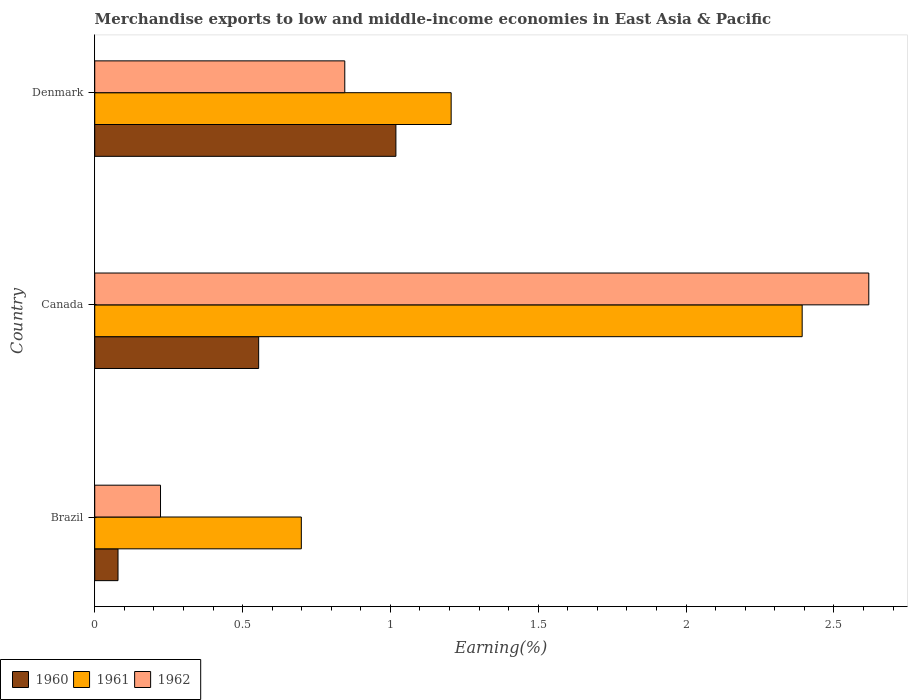How many different coloured bars are there?
Your answer should be compact. 3. How many groups of bars are there?
Your answer should be very brief. 3. Are the number of bars per tick equal to the number of legend labels?
Give a very brief answer. Yes. How many bars are there on the 1st tick from the bottom?
Your response must be concise. 3. What is the label of the 2nd group of bars from the top?
Give a very brief answer. Canada. In how many cases, is the number of bars for a given country not equal to the number of legend labels?
Make the answer very short. 0. What is the percentage of amount earned from merchandise exports in 1962 in Denmark?
Give a very brief answer. 0.85. Across all countries, what is the maximum percentage of amount earned from merchandise exports in 1960?
Your response must be concise. 1.02. Across all countries, what is the minimum percentage of amount earned from merchandise exports in 1962?
Keep it short and to the point. 0.22. What is the total percentage of amount earned from merchandise exports in 1961 in the graph?
Ensure brevity in your answer.  4.3. What is the difference between the percentage of amount earned from merchandise exports in 1961 in Brazil and that in Canada?
Make the answer very short. -1.69. What is the difference between the percentage of amount earned from merchandise exports in 1961 in Denmark and the percentage of amount earned from merchandise exports in 1962 in Canada?
Provide a succinct answer. -1.41. What is the average percentage of amount earned from merchandise exports in 1960 per country?
Provide a short and direct response. 0.55. What is the difference between the percentage of amount earned from merchandise exports in 1962 and percentage of amount earned from merchandise exports in 1961 in Denmark?
Ensure brevity in your answer.  -0.36. In how many countries, is the percentage of amount earned from merchandise exports in 1960 greater than 2.1 %?
Your response must be concise. 0. What is the ratio of the percentage of amount earned from merchandise exports in 1961 in Brazil to that in Denmark?
Make the answer very short. 0.58. Is the percentage of amount earned from merchandise exports in 1961 in Brazil less than that in Denmark?
Ensure brevity in your answer.  Yes. What is the difference between the highest and the second highest percentage of amount earned from merchandise exports in 1962?
Your response must be concise. 1.77. What is the difference between the highest and the lowest percentage of amount earned from merchandise exports in 1962?
Provide a succinct answer. 2.4. Is the sum of the percentage of amount earned from merchandise exports in 1961 in Brazil and Canada greater than the maximum percentage of amount earned from merchandise exports in 1962 across all countries?
Your answer should be compact. Yes. Is it the case that in every country, the sum of the percentage of amount earned from merchandise exports in 1960 and percentage of amount earned from merchandise exports in 1961 is greater than the percentage of amount earned from merchandise exports in 1962?
Keep it short and to the point. Yes. How many bars are there?
Your response must be concise. 9. Does the graph contain any zero values?
Offer a terse response. No. Where does the legend appear in the graph?
Your answer should be very brief. Bottom left. How many legend labels are there?
Provide a short and direct response. 3. How are the legend labels stacked?
Provide a short and direct response. Horizontal. What is the title of the graph?
Your response must be concise. Merchandise exports to low and middle-income economies in East Asia & Pacific. What is the label or title of the X-axis?
Provide a short and direct response. Earning(%). What is the Earning(%) in 1960 in Brazil?
Offer a terse response. 0.08. What is the Earning(%) in 1961 in Brazil?
Offer a very short reply. 0.7. What is the Earning(%) of 1962 in Brazil?
Provide a succinct answer. 0.22. What is the Earning(%) of 1960 in Canada?
Provide a short and direct response. 0.55. What is the Earning(%) of 1961 in Canada?
Offer a terse response. 2.39. What is the Earning(%) of 1962 in Canada?
Your answer should be compact. 2.62. What is the Earning(%) in 1960 in Denmark?
Offer a terse response. 1.02. What is the Earning(%) in 1961 in Denmark?
Your response must be concise. 1.21. What is the Earning(%) of 1962 in Denmark?
Keep it short and to the point. 0.85. Across all countries, what is the maximum Earning(%) of 1960?
Give a very brief answer. 1.02. Across all countries, what is the maximum Earning(%) of 1961?
Keep it short and to the point. 2.39. Across all countries, what is the maximum Earning(%) in 1962?
Your response must be concise. 2.62. Across all countries, what is the minimum Earning(%) of 1960?
Your answer should be very brief. 0.08. Across all countries, what is the minimum Earning(%) in 1961?
Your response must be concise. 0.7. Across all countries, what is the minimum Earning(%) in 1962?
Provide a succinct answer. 0.22. What is the total Earning(%) in 1960 in the graph?
Provide a short and direct response. 1.65. What is the total Earning(%) in 1961 in the graph?
Your answer should be very brief. 4.3. What is the total Earning(%) in 1962 in the graph?
Offer a terse response. 3.69. What is the difference between the Earning(%) in 1960 in Brazil and that in Canada?
Provide a succinct answer. -0.48. What is the difference between the Earning(%) in 1961 in Brazil and that in Canada?
Keep it short and to the point. -1.69. What is the difference between the Earning(%) of 1962 in Brazil and that in Canada?
Your answer should be very brief. -2.4. What is the difference between the Earning(%) of 1960 in Brazil and that in Denmark?
Ensure brevity in your answer.  -0.94. What is the difference between the Earning(%) in 1961 in Brazil and that in Denmark?
Your answer should be very brief. -0.51. What is the difference between the Earning(%) in 1962 in Brazil and that in Denmark?
Give a very brief answer. -0.62. What is the difference between the Earning(%) of 1960 in Canada and that in Denmark?
Provide a succinct answer. -0.46. What is the difference between the Earning(%) of 1961 in Canada and that in Denmark?
Your response must be concise. 1.19. What is the difference between the Earning(%) of 1962 in Canada and that in Denmark?
Give a very brief answer. 1.77. What is the difference between the Earning(%) in 1960 in Brazil and the Earning(%) in 1961 in Canada?
Keep it short and to the point. -2.31. What is the difference between the Earning(%) in 1960 in Brazil and the Earning(%) in 1962 in Canada?
Provide a short and direct response. -2.54. What is the difference between the Earning(%) of 1961 in Brazil and the Earning(%) of 1962 in Canada?
Give a very brief answer. -1.92. What is the difference between the Earning(%) in 1960 in Brazil and the Earning(%) in 1961 in Denmark?
Provide a succinct answer. -1.13. What is the difference between the Earning(%) of 1960 in Brazil and the Earning(%) of 1962 in Denmark?
Your answer should be compact. -0.77. What is the difference between the Earning(%) of 1961 in Brazil and the Earning(%) of 1962 in Denmark?
Give a very brief answer. -0.15. What is the difference between the Earning(%) in 1960 in Canada and the Earning(%) in 1961 in Denmark?
Provide a succinct answer. -0.65. What is the difference between the Earning(%) of 1960 in Canada and the Earning(%) of 1962 in Denmark?
Provide a short and direct response. -0.29. What is the difference between the Earning(%) of 1961 in Canada and the Earning(%) of 1962 in Denmark?
Your response must be concise. 1.55. What is the average Earning(%) of 1960 per country?
Give a very brief answer. 0.55. What is the average Earning(%) of 1961 per country?
Your response must be concise. 1.43. What is the average Earning(%) of 1962 per country?
Offer a terse response. 1.23. What is the difference between the Earning(%) of 1960 and Earning(%) of 1961 in Brazil?
Your response must be concise. -0.62. What is the difference between the Earning(%) in 1960 and Earning(%) in 1962 in Brazil?
Provide a succinct answer. -0.14. What is the difference between the Earning(%) of 1961 and Earning(%) of 1962 in Brazil?
Offer a very short reply. 0.48. What is the difference between the Earning(%) of 1960 and Earning(%) of 1961 in Canada?
Keep it short and to the point. -1.84. What is the difference between the Earning(%) of 1960 and Earning(%) of 1962 in Canada?
Provide a short and direct response. -2.06. What is the difference between the Earning(%) in 1961 and Earning(%) in 1962 in Canada?
Your answer should be very brief. -0.23. What is the difference between the Earning(%) of 1960 and Earning(%) of 1961 in Denmark?
Offer a terse response. -0.19. What is the difference between the Earning(%) in 1960 and Earning(%) in 1962 in Denmark?
Offer a terse response. 0.17. What is the difference between the Earning(%) of 1961 and Earning(%) of 1962 in Denmark?
Give a very brief answer. 0.36. What is the ratio of the Earning(%) in 1960 in Brazil to that in Canada?
Make the answer very short. 0.14. What is the ratio of the Earning(%) in 1961 in Brazil to that in Canada?
Keep it short and to the point. 0.29. What is the ratio of the Earning(%) of 1962 in Brazil to that in Canada?
Keep it short and to the point. 0.09. What is the ratio of the Earning(%) in 1960 in Brazil to that in Denmark?
Provide a succinct answer. 0.08. What is the ratio of the Earning(%) in 1961 in Brazil to that in Denmark?
Make the answer very short. 0.58. What is the ratio of the Earning(%) in 1962 in Brazil to that in Denmark?
Offer a terse response. 0.26. What is the ratio of the Earning(%) in 1960 in Canada to that in Denmark?
Offer a terse response. 0.54. What is the ratio of the Earning(%) of 1961 in Canada to that in Denmark?
Offer a very short reply. 1.98. What is the ratio of the Earning(%) of 1962 in Canada to that in Denmark?
Keep it short and to the point. 3.1. What is the difference between the highest and the second highest Earning(%) in 1960?
Keep it short and to the point. 0.46. What is the difference between the highest and the second highest Earning(%) of 1961?
Provide a succinct answer. 1.19. What is the difference between the highest and the second highest Earning(%) in 1962?
Offer a very short reply. 1.77. What is the difference between the highest and the lowest Earning(%) in 1960?
Keep it short and to the point. 0.94. What is the difference between the highest and the lowest Earning(%) in 1961?
Offer a very short reply. 1.69. What is the difference between the highest and the lowest Earning(%) in 1962?
Offer a terse response. 2.4. 